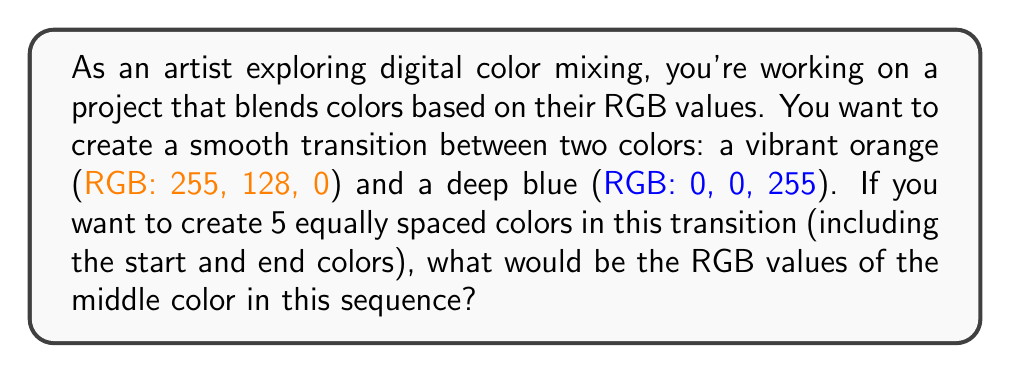What is the answer to this math problem? To solve this problem, we need to use linear interpolation between the RGB values of the two given colors. Here's how we can approach this:

1. Identify the start and end points:
   Start (orange): $R_1 = 255$, $G_1 = 128$, $B_1 = 0$
   End (blue): $R_2 = 0$, $G_2 = 0$, $B_2 = 255$

2. Calculate the total change in each channel:
   $\Delta R = R_2 - R_1 = 0 - 255 = -255$
   $\Delta G = G_2 - G_1 = 0 - 128 = -128$
   $\Delta B = B_2 - B_1 = 255 - 0 = 255$

3. Determine the step size for each channel:
   We want 5 colors, so there are 4 intervals between them.
   Step size for each channel = Total change / Number of intervals
   $Step_R = -255 / 4 = -63.75$
   $Step_G = -128 / 4 = -32$
   $Step_B = 255 / 4 = 63.75$

4. Calculate the middle color (3rd in the sequence):
   It's 2 steps away from the start color.
   $R_{middle} = R_1 + 2 * Step_R = 255 + 2 * (-63.75) = 127.5$
   $G_{middle} = G_1 + 2 * Step_G = 128 + 2 * (-32) = 64$
   $B_{middle} = B_1 + 2 * Step_B = 0 + 2 * 63.75 = 127.5$

5. Round the values to the nearest integer (as RGB values are typically whole numbers):
   $R_{middle} \approx 128$
   $G_{middle} = 64$
   $B_{middle} \approx 128$

Therefore, the RGB values of the middle color in the transition sequence are (128, 64, 128).
Answer: (128, 64, 128) 